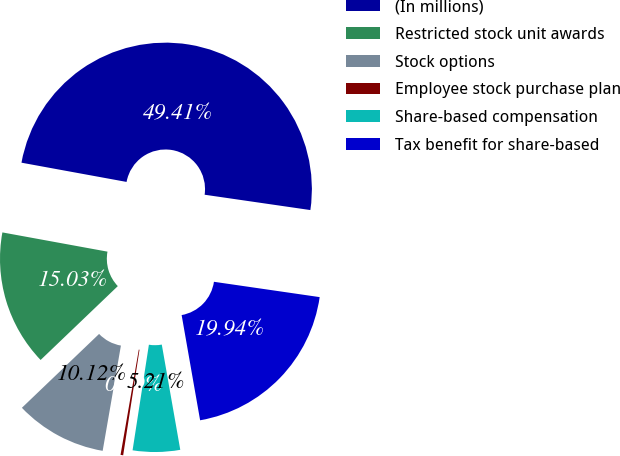Convert chart to OTSL. <chart><loc_0><loc_0><loc_500><loc_500><pie_chart><fcel>(In millions)<fcel>Restricted stock unit awards<fcel>Stock options<fcel>Employee stock purchase plan<fcel>Share-based compensation<fcel>Tax benefit for share-based<nl><fcel>49.41%<fcel>15.03%<fcel>10.12%<fcel>0.29%<fcel>5.21%<fcel>19.94%<nl></chart> 